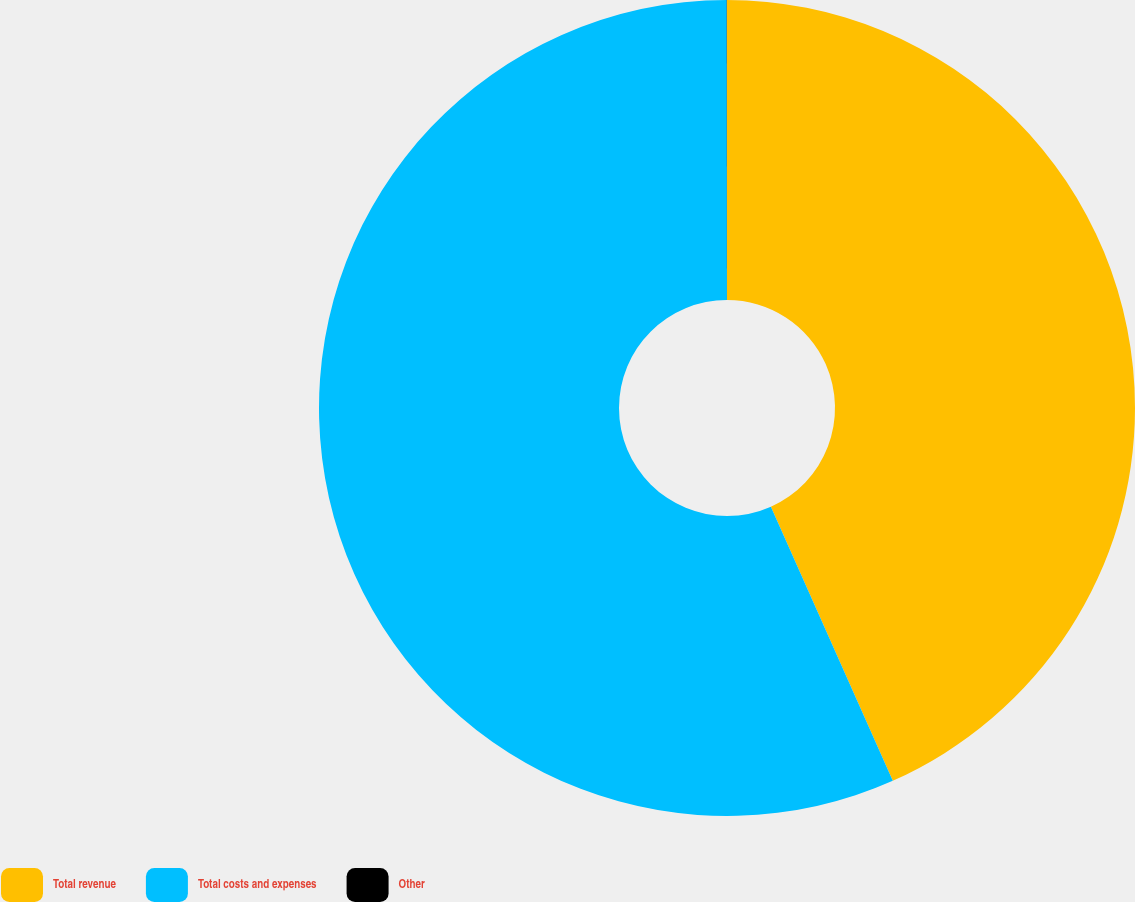<chart> <loc_0><loc_0><loc_500><loc_500><pie_chart><fcel>Total revenue<fcel>Total costs and expenses<fcel>Other<nl><fcel>43.34%<fcel>56.65%<fcel>0.01%<nl></chart> 